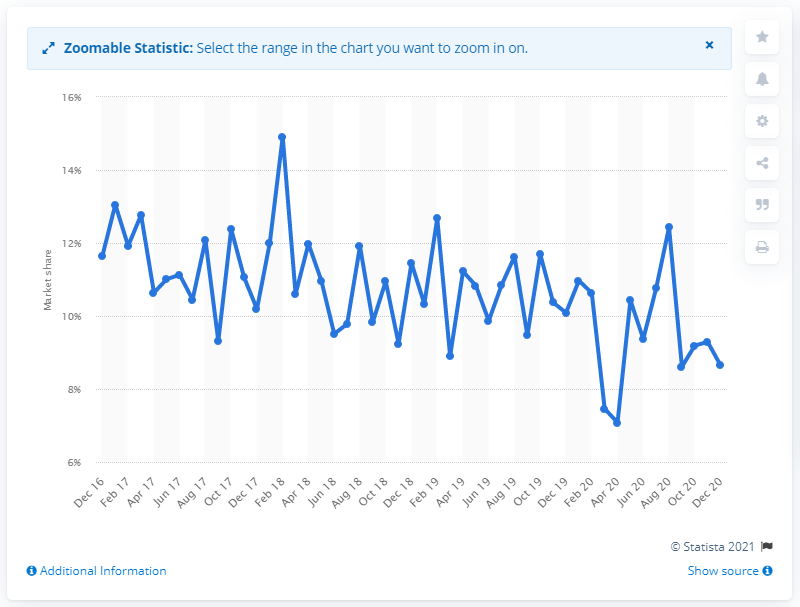Identify some key points in this picture. During the period of December 2016 to December 2020, Ford's market share had a range of 8.65%. As of December 2020, Ford's market share was 8.65%. 